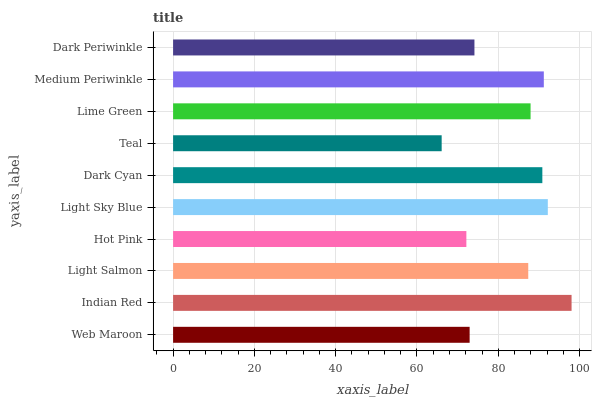Is Teal the minimum?
Answer yes or no. Yes. Is Indian Red the maximum?
Answer yes or no. Yes. Is Light Salmon the minimum?
Answer yes or no. No. Is Light Salmon the maximum?
Answer yes or no. No. Is Indian Red greater than Light Salmon?
Answer yes or no. Yes. Is Light Salmon less than Indian Red?
Answer yes or no. Yes. Is Light Salmon greater than Indian Red?
Answer yes or no. No. Is Indian Red less than Light Salmon?
Answer yes or no. No. Is Lime Green the high median?
Answer yes or no. Yes. Is Light Salmon the low median?
Answer yes or no. Yes. Is Light Salmon the high median?
Answer yes or no. No. Is Medium Periwinkle the low median?
Answer yes or no. No. 